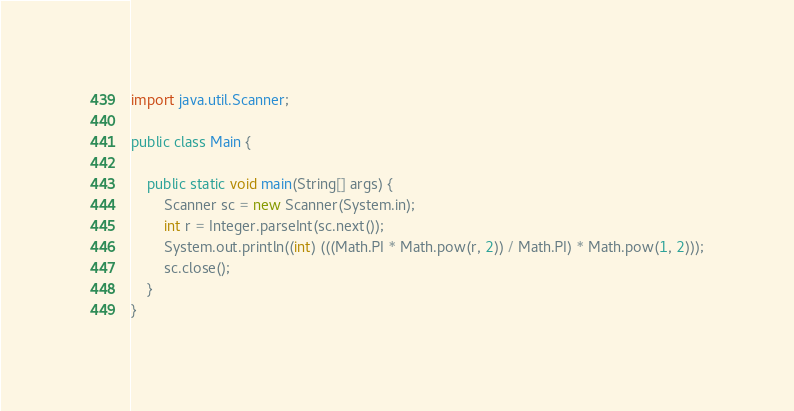<code> <loc_0><loc_0><loc_500><loc_500><_Java_>import java.util.Scanner;

public class Main {

    public static void main(String[] args) {
        Scanner sc = new Scanner(System.in);
        int r = Integer.parseInt(sc.next());
        System.out.println((int) (((Math.PI * Math.pow(r, 2)) / Math.PI) * Math.pow(1, 2)));
        sc.close();
    }
}
</code> 